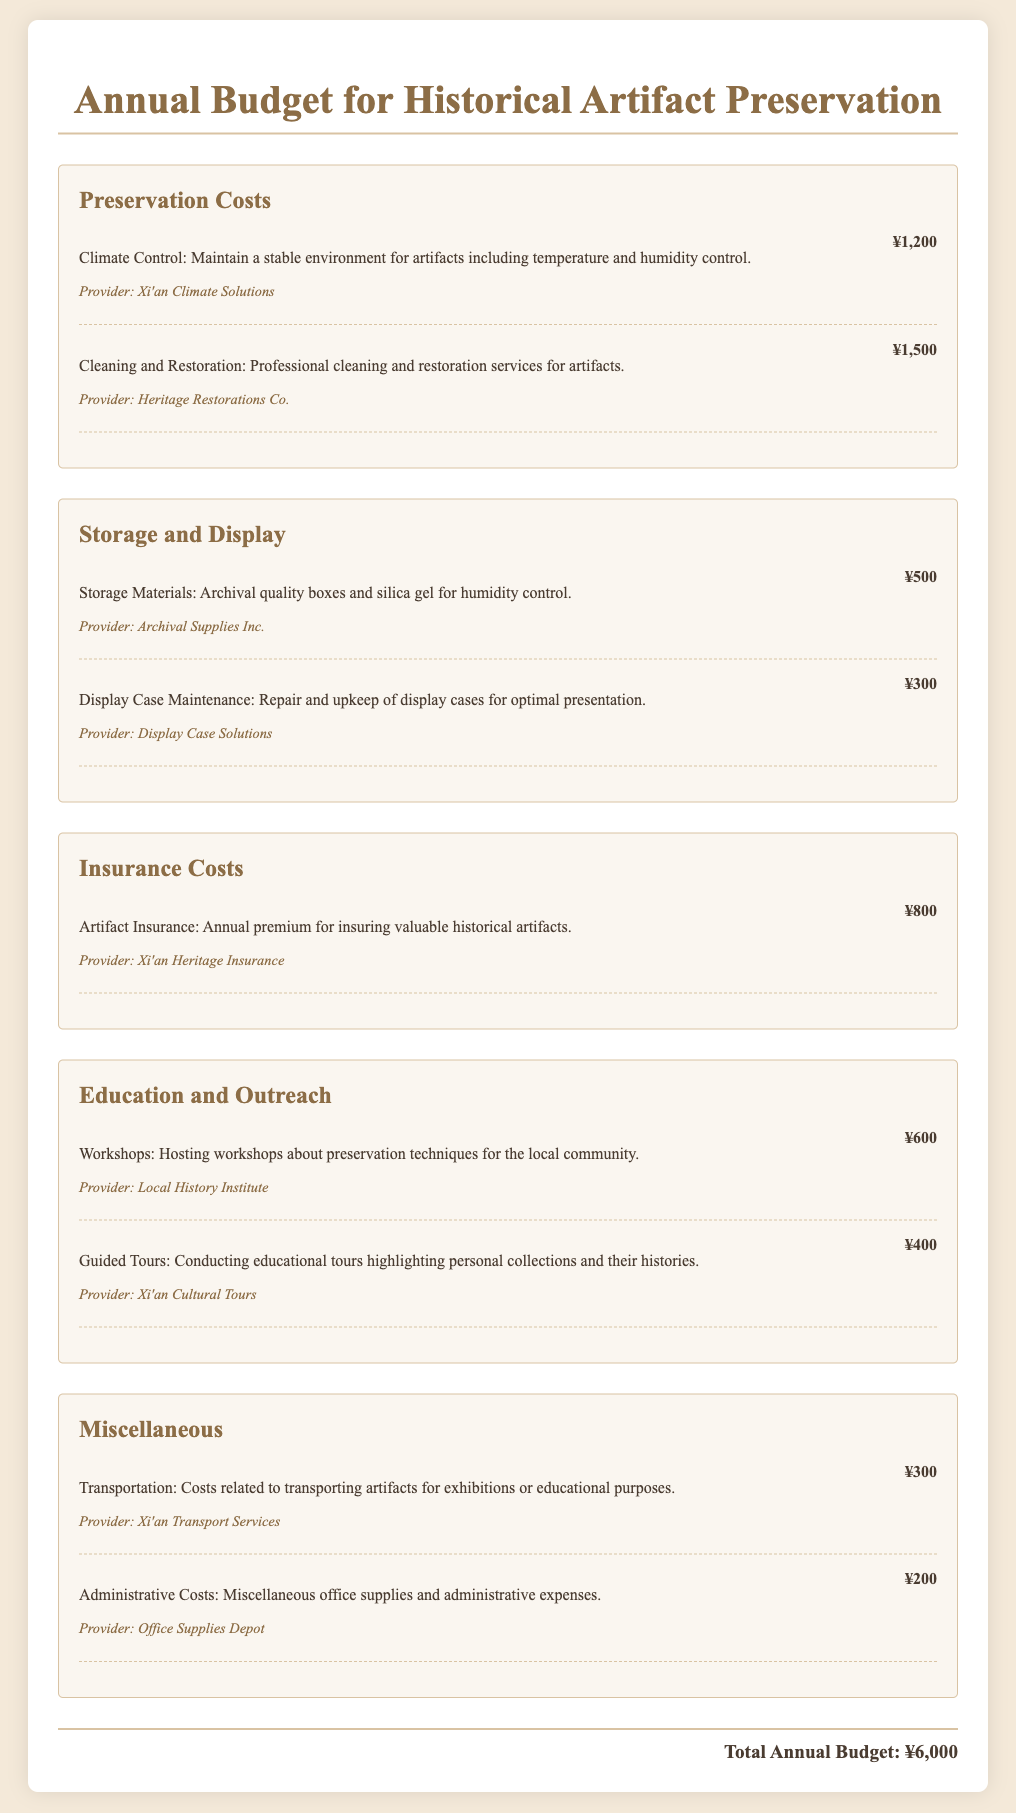What is the total annual budget? The total annual budget is given in the document at the end, which sums up all the expenses.
Answer: ¥6,000 Who provides climate control services? The provider for climate control services is mentioned in the expenses section of the document.
Answer: Xi'an Climate Solutions How much is allocated for artifact insurance? The amount for artifact insurance is stated in the insurance costs category.
Answer: ¥800 What is the cost for cleaning and restoration? The expense for cleaning and restoration can be found in the preservation costs section of the document.
Answer: ¥1,500 What type of workshops are hosted? The type of workshops is described in the education and outreach section and specifies the subject matter.
Answer: Preservation techniques Which provider is responsible for display case maintenance? The provider responsible for display case maintenance is listed in the storage and display category.
Answer: Display Case Solutions What materials are included under storage materials? The document specifies the items included in the storage materials expense.
Answer: Archival quality boxes and silica gel How much is the expense for administrative costs? The amount for administrative costs is mentioned in the miscellaneous section of the document.
Answer: ¥200 